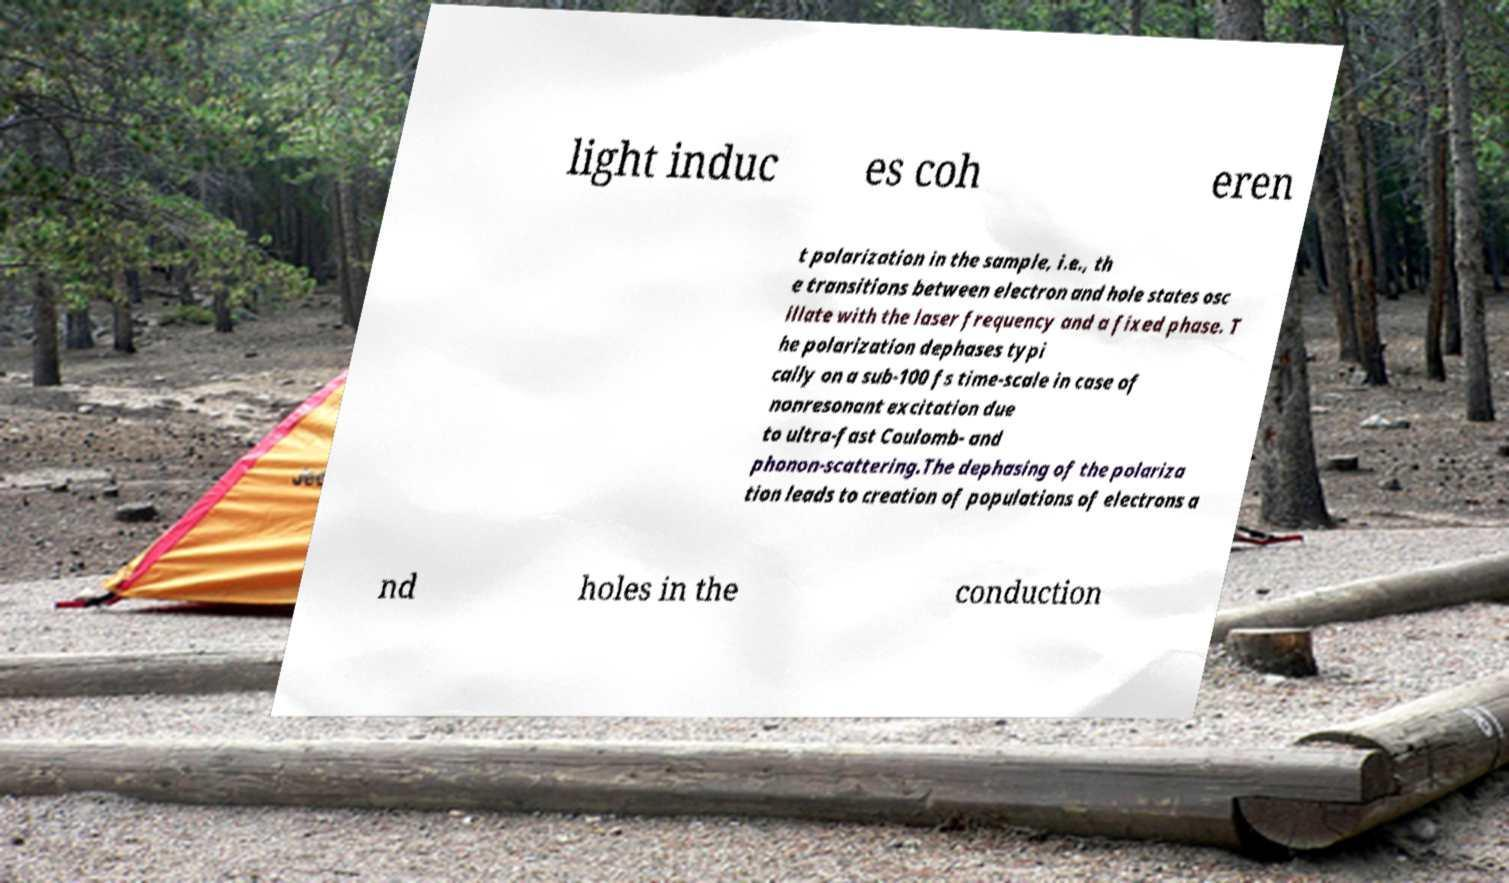Please read and relay the text visible in this image. What does it say? light induc es coh eren t polarization in the sample, i.e., th e transitions between electron and hole states osc illate with the laser frequency and a fixed phase. T he polarization dephases typi cally on a sub-100 fs time-scale in case of nonresonant excitation due to ultra-fast Coulomb- and phonon-scattering.The dephasing of the polariza tion leads to creation of populations of electrons a nd holes in the conduction 